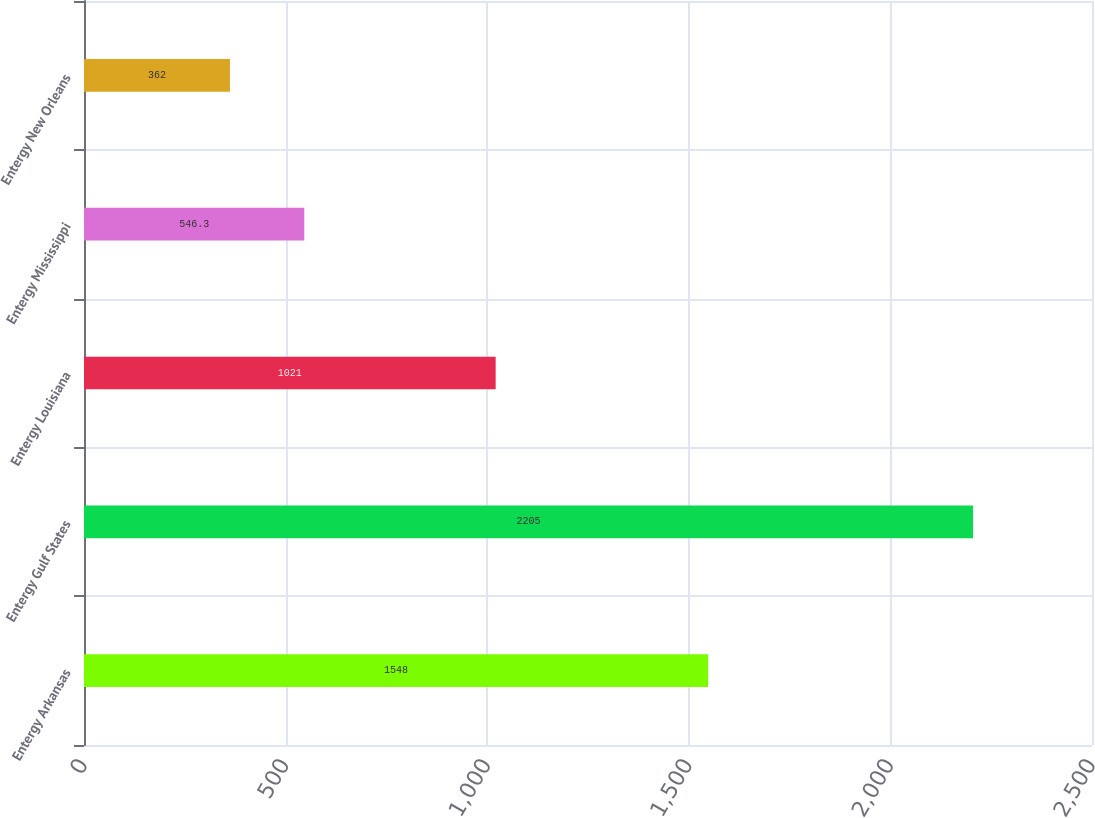Convert chart to OTSL. <chart><loc_0><loc_0><loc_500><loc_500><bar_chart><fcel>Entergy Arkansas<fcel>Entergy Gulf States<fcel>Entergy Louisiana<fcel>Entergy Mississippi<fcel>Entergy New Orleans<nl><fcel>1548<fcel>2205<fcel>1021<fcel>546.3<fcel>362<nl></chart> 